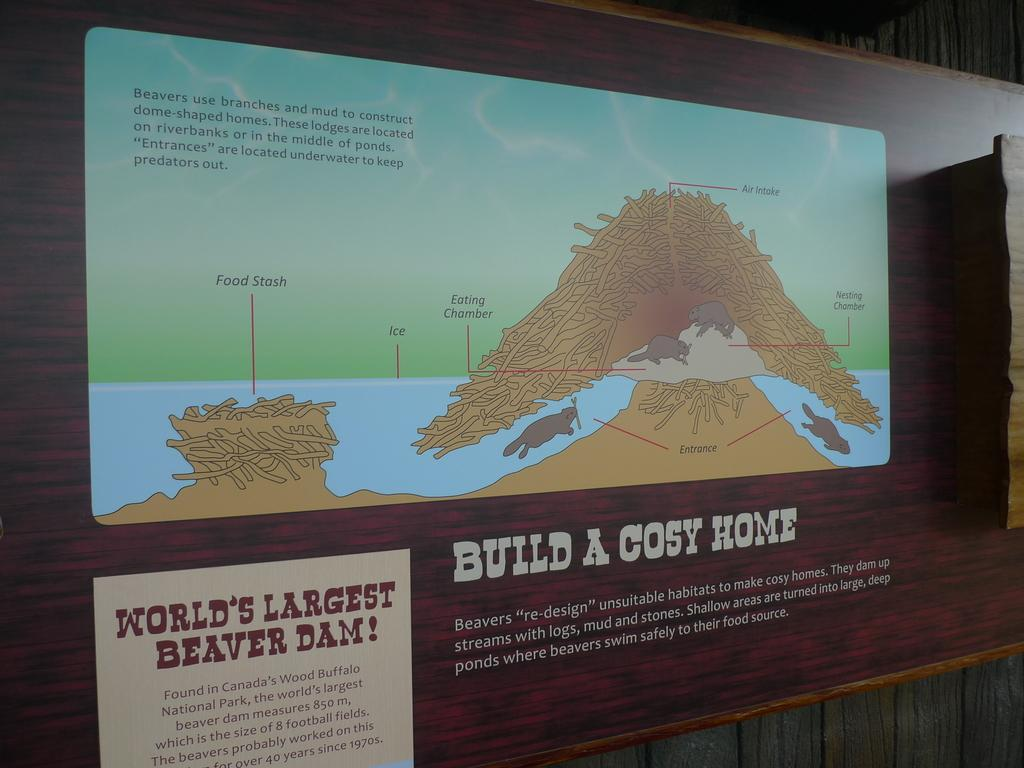<image>
Give a short and clear explanation of the subsequent image. A large wall mural displays information about the world's largest beaver dam and how beavers build a cosy home. 